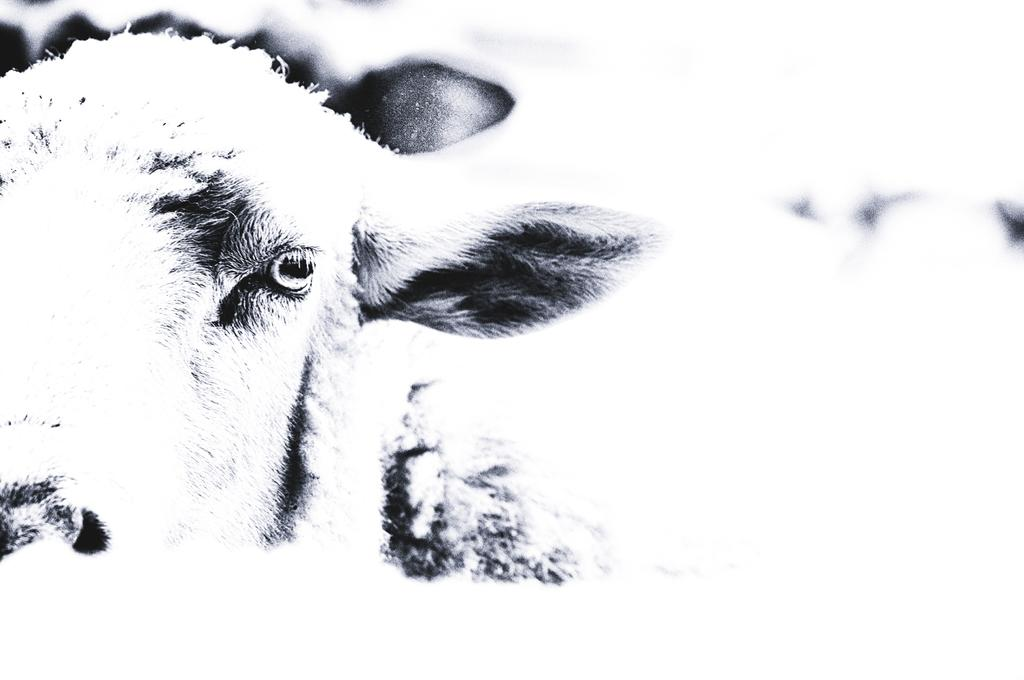What is located in the left corner of the image? There is an animal in the left corner of the image. What type of tray is being smashed by the animal in the image? There is no tray present in the image, nor is the animal smashing anything. 